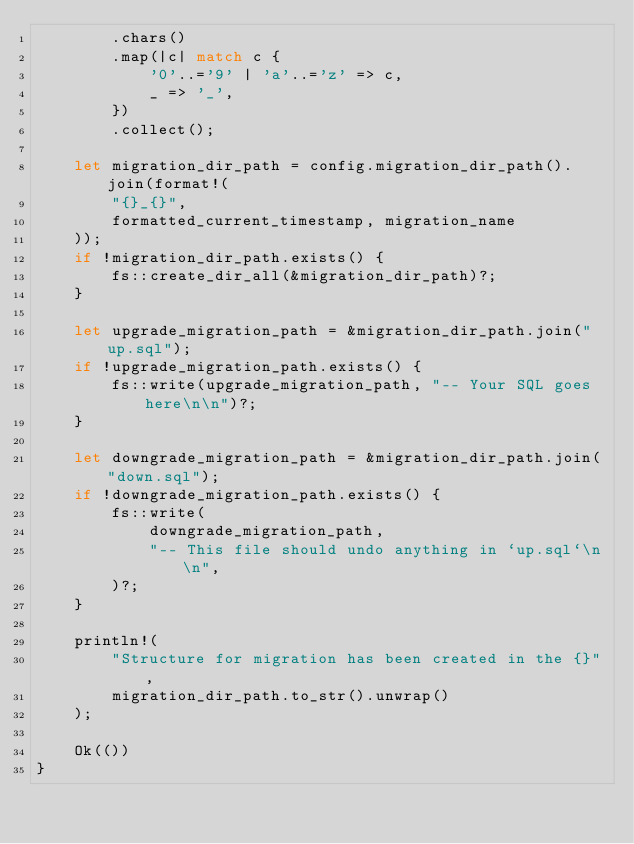Convert code to text. <code><loc_0><loc_0><loc_500><loc_500><_Rust_>        .chars()
        .map(|c| match c {
            '0'..='9' | 'a'..='z' => c,
            _ => '_',
        })
        .collect();

    let migration_dir_path = config.migration_dir_path().join(format!(
        "{}_{}",
        formatted_current_timestamp, migration_name
    ));
    if !migration_dir_path.exists() {
        fs::create_dir_all(&migration_dir_path)?;
    }

    let upgrade_migration_path = &migration_dir_path.join("up.sql");
    if !upgrade_migration_path.exists() {
        fs::write(upgrade_migration_path, "-- Your SQL goes here\n\n")?;
    }

    let downgrade_migration_path = &migration_dir_path.join("down.sql");
    if !downgrade_migration_path.exists() {
        fs::write(
            downgrade_migration_path,
            "-- This file should undo anything in `up.sql`\n\n",
        )?;
    }

    println!(
        "Structure for migration has been created in the {}",
        migration_dir_path.to_str().unwrap()
    );

    Ok(())
}
</code> 